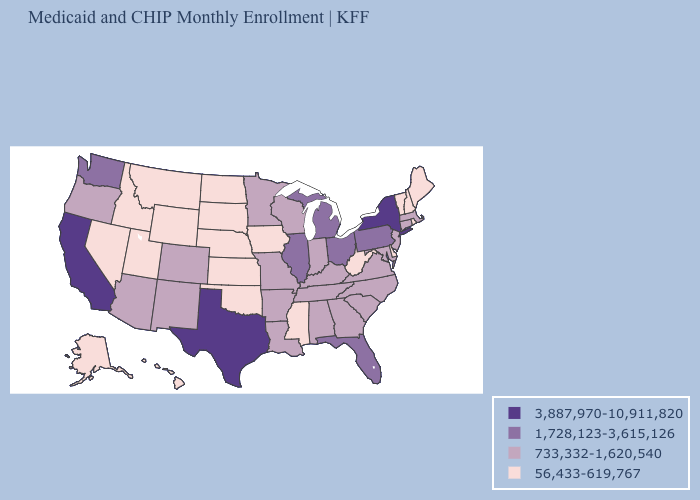Among the states that border Maryland , does West Virginia have the highest value?
Answer briefly. No. Name the states that have a value in the range 1,728,123-3,615,126?
Write a very short answer. Florida, Illinois, Michigan, Ohio, Pennsylvania, Washington. Name the states that have a value in the range 733,332-1,620,540?
Write a very short answer. Alabama, Arizona, Arkansas, Colorado, Connecticut, Georgia, Indiana, Kentucky, Louisiana, Maryland, Massachusetts, Minnesota, Missouri, New Jersey, New Mexico, North Carolina, Oregon, South Carolina, Tennessee, Virginia, Wisconsin. Does Hawaii have the same value as Michigan?
Write a very short answer. No. Name the states that have a value in the range 1,728,123-3,615,126?
Answer briefly. Florida, Illinois, Michigan, Ohio, Pennsylvania, Washington. Does Illinois have the same value as Michigan?
Answer briefly. Yes. Which states have the highest value in the USA?
Give a very brief answer. California, New York, Texas. Does New Jersey have a higher value than Utah?
Concise answer only. Yes. What is the value of Mississippi?
Short answer required. 56,433-619,767. What is the lowest value in the USA?
Be succinct. 56,433-619,767. Does Nevada have the lowest value in the USA?
Short answer required. Yes. Does Utah have a higher value than Oklahoma?
Be succinct. No. What is the value of Maine?
Give a very brief answer. 56,433-619,767. What is the value of Hawaii?
Keep it brief. 56,433-619,767. 